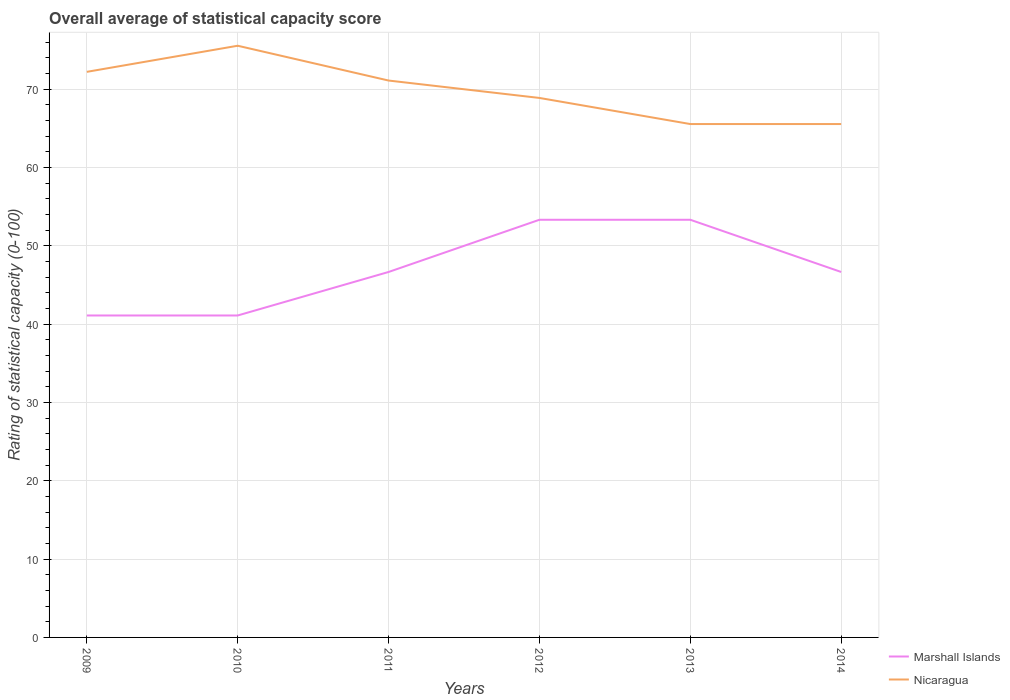How many different coloured lines are there?
Offer a terse response. 2. Does the line corresponding to Marshall Islands intersect with the line corresponding to Nicaragua?
Provide a succinct answer. No. Across all years, what is the maximum rating of statistical capacity in Nicaragua?
Provide a short and direct response. 65.56. What is the total rating of statistical capacity in Nicaragua in the graph?
Give a very brief answer. 10. What is the difference between the highest and the second highest rating of statistical capacity in Nicaragua?
Make the answer very short. 10. How many lines are there?
Provide a succinct answer. 2. How many years are there in the graph?
Make the answer very short. 6. What is the difference between two consecutive major ticks on the Y-axis?
Provide a short and direct response. 10. Does the graph contain any zero values?
Make the answer very short. No. What is the title of the graph?
Provide a short and direct response. Overall average of statistical capacity score. What is the label or title of the X-axis?
Offer a very short reply. Years. What is the label or title of the Y-axis?
Give a very brief answer. Rating of statistical capacity (0-100). What is the Rating of statistical capacity (0-100) in Marshall Islands in 2009?
Offer a very short reply. 41.11. What is the Rating of statistical capacity (0-100) of Nicaragua in 2009?
Make the answer very short. 72.22. What is the Rating of statistical capacity (0-100) of Marshall Islands in 2010?
Keep it short and to the point. 41.11. What is the Rating of statistical capacity (0-100) of Nicaragua in 2010?
Give a very brief answer. 75.56. What is the Rating of statistical capacity (0-100) of Marshall Islands in 2011?
Your answer should be compact. 46.67. What is the Rating of statistical capacity (0-100) in Nicaragua in 2011?
Your response must be concise. 71.11. What is the Rating of statistical capacity (0-100) in Marshall Islands in 2012?
Keep it short and to the point. 53.33. What is the Rating of statistical capacity (0-100) in Nicaragua in 2012?
Ensure brevity in your answer.  68.89. What is the Rating of statistical capacity (0-100) in Marshall Islands in 2013?
Keep it short and to the point. 53.33. What is the Rating of statistical capacity (0-100) in Nicaragua in 2013?
Your answer should be very brief. 65.56. What is the Rating of statistical capacity (0-100) in Marshall Islands in 2014?
Make the answer very short. 46.67. What is the Rating of statistical capacity (0-100) in Nicaragua in 2014?
Your answer should be compact. 65.56. Across all years, what is the maximum Rating of statistical capacity (0-100) of Marshall Islands?
Ensure brevity in your answer.  53.33. Across all years, what is the maximum Rating of statistical capacity (0-100) in Nicaragua?
Your answer should be very brief. 75.56. Across all years, what is the minimum Rating of statistical capacity (0-100) in Marshall Islands?
Keep it short and to the point. 41.11. Across all years, what is the minimum Rating of statistical capacity (0-100) of Nicaragua?
Keep it short and to the point. 65.56. What is the total Rating of statistical capacity (0-100) of Marshall Islands in the graph?
Your answer should be very brief. 282.22. What is the total Rating of statistical capacity (0-100) in Nicaragua in the graph?
Provide a succinct answer. 418.89. What is the difference between the Rating of statistical capacity (0-100) in Marshall Islands in 2009 and that in 2010?
Ensure brevity in your answer.  0. What is the difference between the Rating of statistical capacity (0-100) in Nicaragua in 2009 and that in 2010?
Ensure brevity in your answer.  -3.33. What is the difference between the Rating of statistical capacity (0-100) of Marshall Islands in 2009 and that in 2011?
Make the answer very short. -5.56. What is the difference between the Rating of statistical capacity (0-100) of Marshall Islands in 2009 and that in 2012?
Make the answer very short. -12.22. What is the difference between the Rating of statistical capacity (0-100) in Marshall Islands in 2009 and that in 2013?
Give a very brief answer. -12.22. What is the difference between the Rating of statistical capacity (0-100) in Nicaragua in 2009 and that in 2013?
Ensure brevity in your answer.  6.67. What is the difference between the Rating of statistical capacity (0-100) in Marshall Islands in 2009 and that in 2014?
Your response must be concise. -5.56. What is the difference between the Rating of statistical capacity (0-100) in Marshall Islands in 2010 and that in 2011?
Your answer should be very brief. -5.56. What is the difference between the Rating of statistical capacity (0-100) in Nicaragua in 2010 and that in 2011?
Give a very brief answer. 4.44. What is the difference between the Rating of statistical capacity (0-100) in Marshall Islands in 2010 and that in 2012?
Give a very brief answer. -12.22. What is the difference between the Rating of statistical capacity (0-100) of Nicaragua in 2010 and that in 2012?
Your response must be concise. 6.67. What is the difference between the Rating of statistical capacity (0-100) of Marshall Islands in 2010 and that in 2013?
Provide a succinct answer. -12.22. What is the difference between the Rating of statistical capacity (0-100) in Marshall Islands in 2010 and that in 2014?
Give a very brief answer. -5.56. What is the difference between the Rating of statistical capacity (0-100) of Nicaragua in 2010 and that in 2014?
Provide a short and direct response. 10. What is the difference between the Rating of statistical capacity (0-100) of Marshall Islands in 2011 and that in 2012?
Give a very brief answer. -6.67. What is the difference between the Rating of statistical capacity (0-100) of Nicaragua in 2011 and that in 2012?
Offer a terse response. 2.22. What is the difference between the Rating of statistical capacity (0-100) of Marshall Islands in 2011 and that in 2013?
Keep it short and to the point. -6.67. What is the difference between the Rating of statistical capacity (0-100) in Nicaragua in 2011 and that in 2013?
Give a very brief answer. 5.56. What is the difference between the Rating of statistical capacity (0-100) of Marshall Islands in 2011 and that in 2014?
Keep it short and to the point. 0. What is the difference between the Rating of statistical capacity (0-100) in Nicaragua in 2011 and that in 2014?
Make the answer very short. 5.56. What is the difference between the Rating of statistical capacity (0-100) of Marshall Islands in 2012 and that in 2013?
Keep it short and to the point. 0. What is the difference between the Rating of statistical capacity (0-100) of Nicaragua in 2012 and that in 2013?
Keep it short and to the point. 3.33. What is the difference between the Rating of statistical capacity (0-100) of Nicaragua in 2012 and that in 2014?
Provide a succinct answer. 3.33. What is the difference between the Rating of statistical capacity (0-100) in Nicaragua in 2013 and that in 2014?
Your response must be concise. 0. What is the difference between the Rating of statistical capacity (0-100) of Marshall Islands in 2009 and the Rating of statistical capacity (0-100) of Nicaragua in 2010?
Ensure brevity in your answer.  -34.44. What is the difference between the Rating of statistical capacity (0-100) in Marshall Islands in 2009 and the Rating of statistical capacity (0-100) in Nicaragua in 2012?
Offer a very short reply. -27.78. What is the difference between the Rating of statistical capacity (0-100) of Marshall Islands in 2009 and the Rating of statistical capacity (0-100) of Nicaragua in 2013?
Offer a terse response. -24.44. What is the difference between the Rating of statistical capacity (0-100) in Marshall Islands in 2009 and the Rating of statistical capacity (0-100) in Nicaragua in 2014?
Your answer should be compact. -24.44. What is the difference between the Rating of statistical capacity (0-100) in Marshall Islands in 2010 and the Rating of statistical capacity (0-100) in Nicaragua in 2011?
Your response must be concise. -30. What is the difference between the Rating of statistical capacity (0-100) in Marshall Islands in 2010 and the Rating of statistical capacity (0-100) in Nicaragua in 2012?
Offer a terse response. -27.78. What is the difference between the Rating of statistical capacity (0-100) in Marshall Islands in 2010 and the Rating of statistical capacity (0-100) in Nicaragua in 2013?
Make the answer very short. -24.44. What is the difference between the Rating of statistical capacity (0-100) of Marshall Islands in 2010 and the Rating of statistical capacity (0-100) of Nicaragua in 2014?
Keep it short and to the point. -24.44. What is the difference between the Rating of statistical capacity (0-100) of Marshall Islands in 2011 and the Rating of statistical capacity (0-100) of Nicaragua in 2012?
Keep it short and to the point. -22.22. What is the difference between the Rating of statistical capacity (0-100) in Marshall Islands in 2011 and the Rating of statistical capacity (0-100) in Nicaragua in 2013?
Make the answer very short. -18.89. What is the difference between the Rating of statistical capacity (0-100) of Marshall Islands in 2011 and the Rating of statistical capacity (0-100) of Nicaragua in 2014?
Make the answer very short. -18.89. What is the difference between the Rating of statistical capacity (0-100) of Marshall Islands in 2012 and the Rating of statistical capacity (0-100) of Nicaragua in 2013?
Your answer should be very brief. -12.22. What is the difference between the Rating of statistical capacity (0-100) of Marshall Islands in 2012 and the Rating of statistical capacity (0-100) of Nicaragua in 2014?
Provide a short and direct response. -12.22. What is the difference between the Rating of statistical capacity (0-100) in Marshall Islands in 2013 and the Rating of statistical capacity (0-100) in Nicaragua in 2014?
Provide a succinct answer. -12.22. What is the average Rating of statistical capacity (0-100) of Marshall Islands per year?
Keep it short and to the point. 47.04. What is the average Rating of statistical capacity (0-100) in Nicaragua per year?
Your answer should be compact. 69.81. In the year 2009, what is the difference between the Rating of statistical capacity (0-100) in Marshall Islands and Rating of statistical capacity (0-100) in Nicaragua?
Offer a terse response. -31.11. In the year 2010, what is the difference between the Rating of statistical capacity (0-100) of Marshall Islands and Rating of statistical capacity (0-100) of Nicaragua?
Make the answer very short. -34.44. In the year 2011, what is the difference between the Rating of statistical capacity (0-100) of Marshall Islands and Rating of statistical capacity (0-100) of Nicaragua?
Ensure brevity in your answer.  -24.44. In the year 2012, what is the difference between the Rating of statistical capacity (0-100) in Marshall Islands and Rating of statistical capacity (0-100) in Nicaragua?
Your answer should be compact. -15.56. In the year 2013, what is the difference between the Rating of statistical capacity (0-100) in Marshall Islands and Rating of statistical capacity (0-100) in Nicaragua?
Your answer should be very brief. -12.22. In the year 2014, what is the difference between the Rating of statistical capacity (0-100) in Marshall Islands and Rating of statistical capacity (0-100) in Nicaragua?
Give a very brief answer. -18.89. What is the ratio of the Rating of statistical capacity (0-100) of Marshall Islands in 2009 to that in 2010?
Provide a succinct answer. 1. What is the ratio of the Rating of statistical capacity (0-100) of Nicaragua in 2009 to that in 2010?
Your answer should be very brief. 0.96. What is the ratio of the Rating of statistical capacity (0-100) in Marshall Islands in 2009 to that in 2011?
Your answer should be very brief. 0.88. What is the ratio of the Rating of statistical capacity (0-100) in Nicaragua in 2009 to that in 2011?
Provide a succinct answer. 1.02. What is the ratio of the Rating of statistical capacity (0-100) of Marshall Islands in 2009 to that in 2012?
Your answer should be compact. 0.77. What is the ratio of the Rating of statistical capacity (0-100) of Nicaragua in 2009 to that in 2012?
Ensure brevity in your answer.  1.05. What is the ratio of the Rating of statistical capacity (0-100) in Marshall Islands in 2009 to that in 2013?
Keep it short and to the point. 0.77. What is the ratio of the Rating of statistical capacity (0-100) in Nicaragua in 2009 to that in 2013?
Your answer should be very brief. 1.1. What is the ratio of the Rating of statistical capacity (0-100) of Marshall Islands in 2009 to that in 2014?
Keep it short and to the point. 0.88. What is the ratio of the Rating of statistical capacity (0-100) in Nicaragua in 2009 to that in 2014?
Make the answer very short. 1.1. What is the ratio of the Rating of statistical capacity (0-100) of Marshall Islands in 2010 to that in 2011?
Provide a succinct answer. 0.88. What is the ratio of the Rating of statistical capacity (0-100) of Marshall Islands in 2010 to that in 2012?
Make the answer very short. 0.77. What is the ratio of the Rating of statistical capacity (0-100) in Nicaragua in 2010 to that in 2012?
Keep it short and to the point. 1.1. What is the ratio of the Rating of statistical capacity (0-100) of Marshall Islands in 2010 to that in 2013?
Your answer should be compact. 0.77. What is the ratio of the Rating of statistical capacity (0-100) in Nicaragua in 2010 to that in 2013?
Your response must be concise. 1.15. What is the ratio of the Rating of statistical capacity (0-100) of Marshall Islands in 2010 to that in 2014?
Provide a short and direct response. 0.88. What is the ratio of the Rating of statistical capacity (0-100) in Nicaragua in 2010 to that in 2014?
Provide a short and direct response. 1.15. What is the ratio of the Rating of statistical capacity (0-100) in Nicaragua in 2011 to that in 2012?
Your answer should be compact. 1.03. What is the ratio of the Rating of statistical capacity (0-100) of Marshall Islands in 2011 to that in 2013?
Your answer should be very brief. 0.88. What is the ratio of the Rating of statistical capacity (0-100) of Nicaragua in 2011 to that in 2013?
Your answer should be very brief. 1.08. What is the ratio of the Rating of statistical capacity (0-100) of Marshall Islands in 2011 to that in 2014?
Your answer should be very brief. 1. What is the ratio of the Rating of statistical capacity (0-100) in Nicaragua in 2011 to that in 2014?
Provide a succinct answer. 1.08. What is the ratio of the Rating of statistical capacity (0-100) of Nicaragua in 2012 to that in 2013?
Your answer should be compact. 1.05. What is the ratio of the Rating of statistical capacity (0-100) of Nicaragua in 2012 to that in 2014?
Ensure brevity in your answer.  1.05. What is the ratio of the Rating of statistical capacity (0-100) in Nicaragua in 2013 to that in 2014?
Keep it short and to the point. 1. What is the difference between the highest and the lowest Rating of statistical capacity (0-100) in Marshall Islands?
Ensure brevity in your answer.  12.22. 